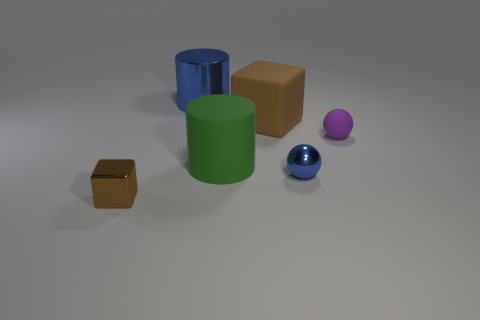What number of other objects are there of the same color as the big metallic thing?
Keep it short and to the point. 1. What number of small gray metallic cylinders are there?
Keep it short and to the point. 0. There is a small ball that is in front of the tiny thing behind the large rubber thing left of the brown matte block; what is its material?
Provide a succinct answer. Metal. There is a brown block behind the small purple rubber sphere; what number of big brown matte things are in front of it?
Keep it short and to the point. 0. There is another tiny object that is the same shape as the small blue thing; what color is it?
Offer a very short reply. Purple. Does the large green object have the same material as the big brown block?
Provide a short and direct response. Yes. How many balls are small blue shiny objects or large rubber objects?
Your answer should be very brief. 1. There is a brown object that is in front of the brown thing that is behind the brown block that is in front of the metal sphere; how big is it?
Your answer should be very brief. Small. There is a rubber object that is the same shape as the brown shiny thing; what size is it?
Offer a terse response. Large. What number of big cubes are in front of the small purple thing?
Provide a short and direct response. 0. 